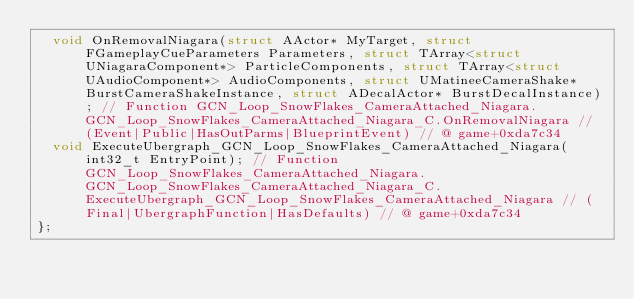<code> <loc_0><loc_0><loc_500><loc_500><_C_>	void OnRemovalNiagara(struct AActor* MyTarget, struct FGameplayCueParameters Parameters, struct TArray<struct UNiagaraComponent*> ParticleComponents, struct TArray<struct UAudioComponent*> AudioComponents, struct UMatineeCameraShake* BurstCameraShakeInstance, struct ADecalActor* BurstDecalInstance); // Function GCN_Loop_SnowFlakes_CameraAttached_Niagara.GCN_Loop_SnowFlakes_CameraAttached_Niagara_C.OnRemovalNiagara // (Event|Public|HasOutParms|BlueprintEvent) // @ game+0xda7c34
	void ExecuteUbergraph_GCN_Loop_SnowFlakes_CameraAttached_Niagara(int32_t EntryPoint); // Function GCN_Loop_SnowFlakes_CameraAttached_Niagara.GCN_Loop_SnowFlakes_CameraAttached_Niagara_C.ExecuteUbergraph_GCN_Loop_SnowFlakes_CameraAttached_Niagara // (Final|UbergraphFunction|HasDefaults) // @ game+0xda7c34
};

</code> 